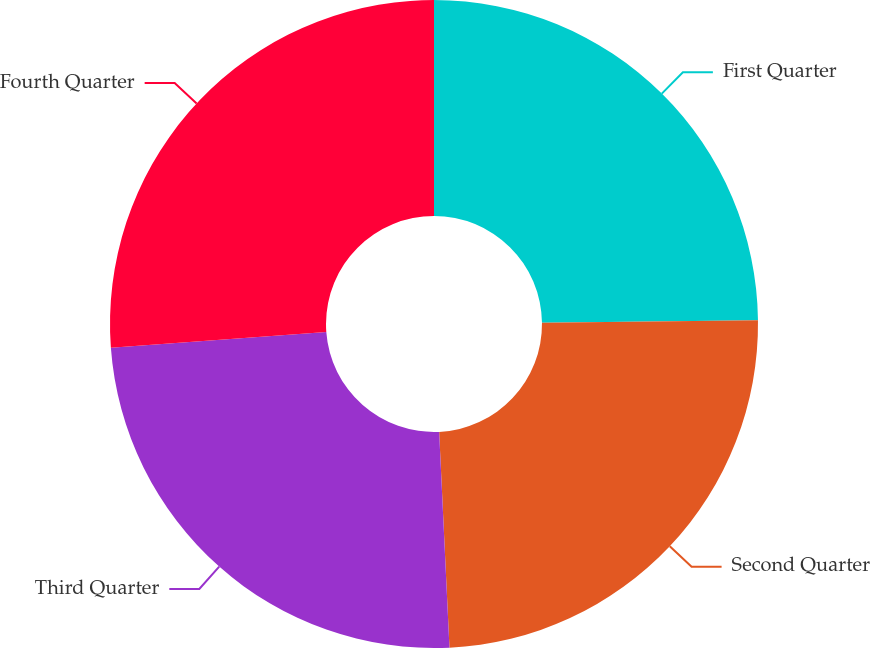<chart> <loc_0><loc_0><loc_500><loc_500><pie_chart><fcel>First Quarter<fcel>Second Quarter<fcel>Third Quarter<fcel>Fourth Quarter<nl><fcel>24.82%<fcel>24.42%<fcel>24.59%<fcel>26.17%<nl></chart> 